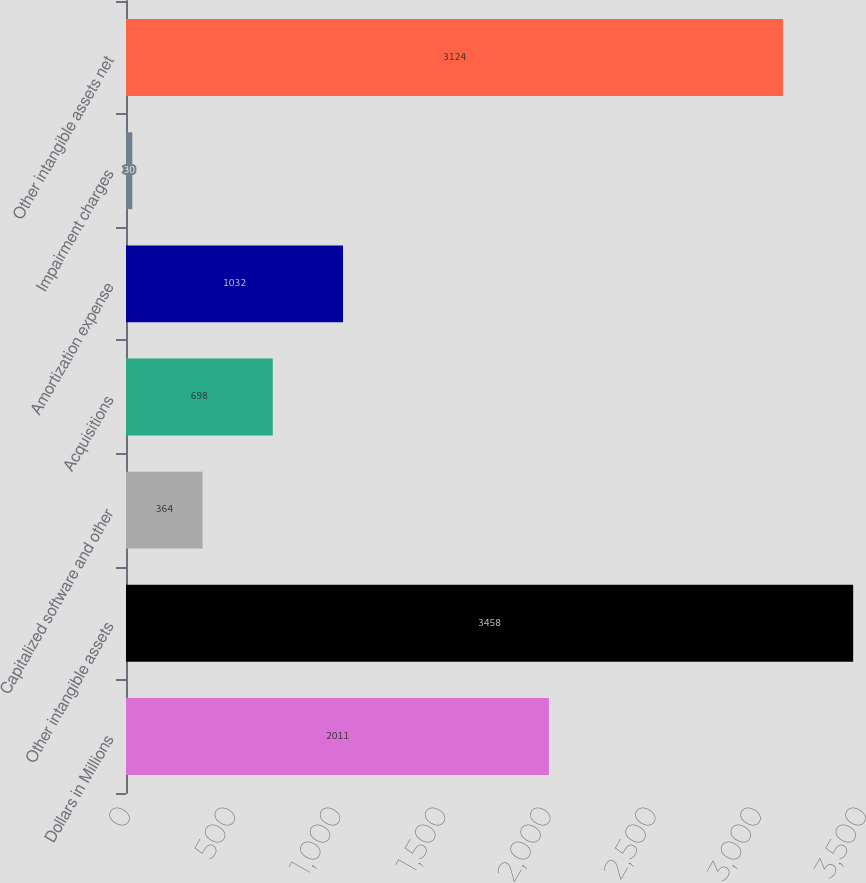<chart> <loc_0><loc_0><loc_500><loc_500><bar_chart><fcel>Dollars in Millions<fcel>Other intangible assets<fcel>Capitalized software and other<fcel>Acquisitions<fcel>Amortization expense<fcel>Impairment charges<fcel>Other intangible assets net<nl><fcel>2011<fcel>3458<fcel>364<fcel>698<fcel>1032<fcel>30<fcel>3124<nl></chart> 